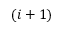<formula> <loc_0><loc_0><loc_500><loc_500>( i + 1 )</formula> 